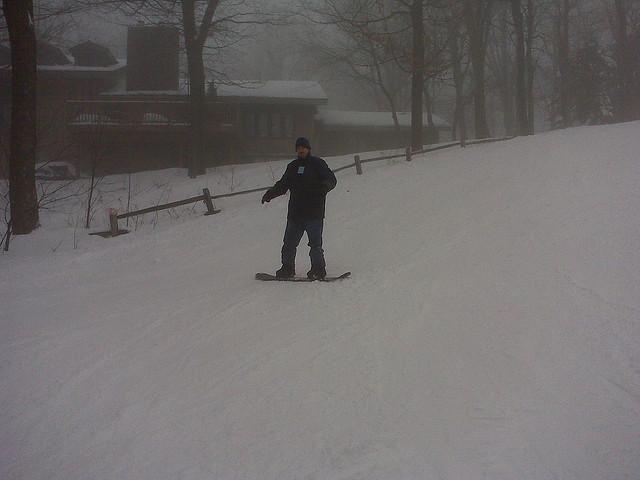How many levels are there to the building in the background?
Give a very brief answer. 3. 